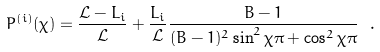Convert formula to latex. <formula><loc_0><loc_0><loc_500><loc_500>P ^ { ( i ) } ( \chi ) = \frac { \mathcal { L } - L _ { i } } { \mathcal { L } } + \frac { L _ { i } } { \mathcal { L } } \frac { B - 1 } { ( B - 1 ) ^ { 2 } \sin ^ { 2 } \chi \pi + \cos ^ { 2 } \chi \pi } \ .</formula> 